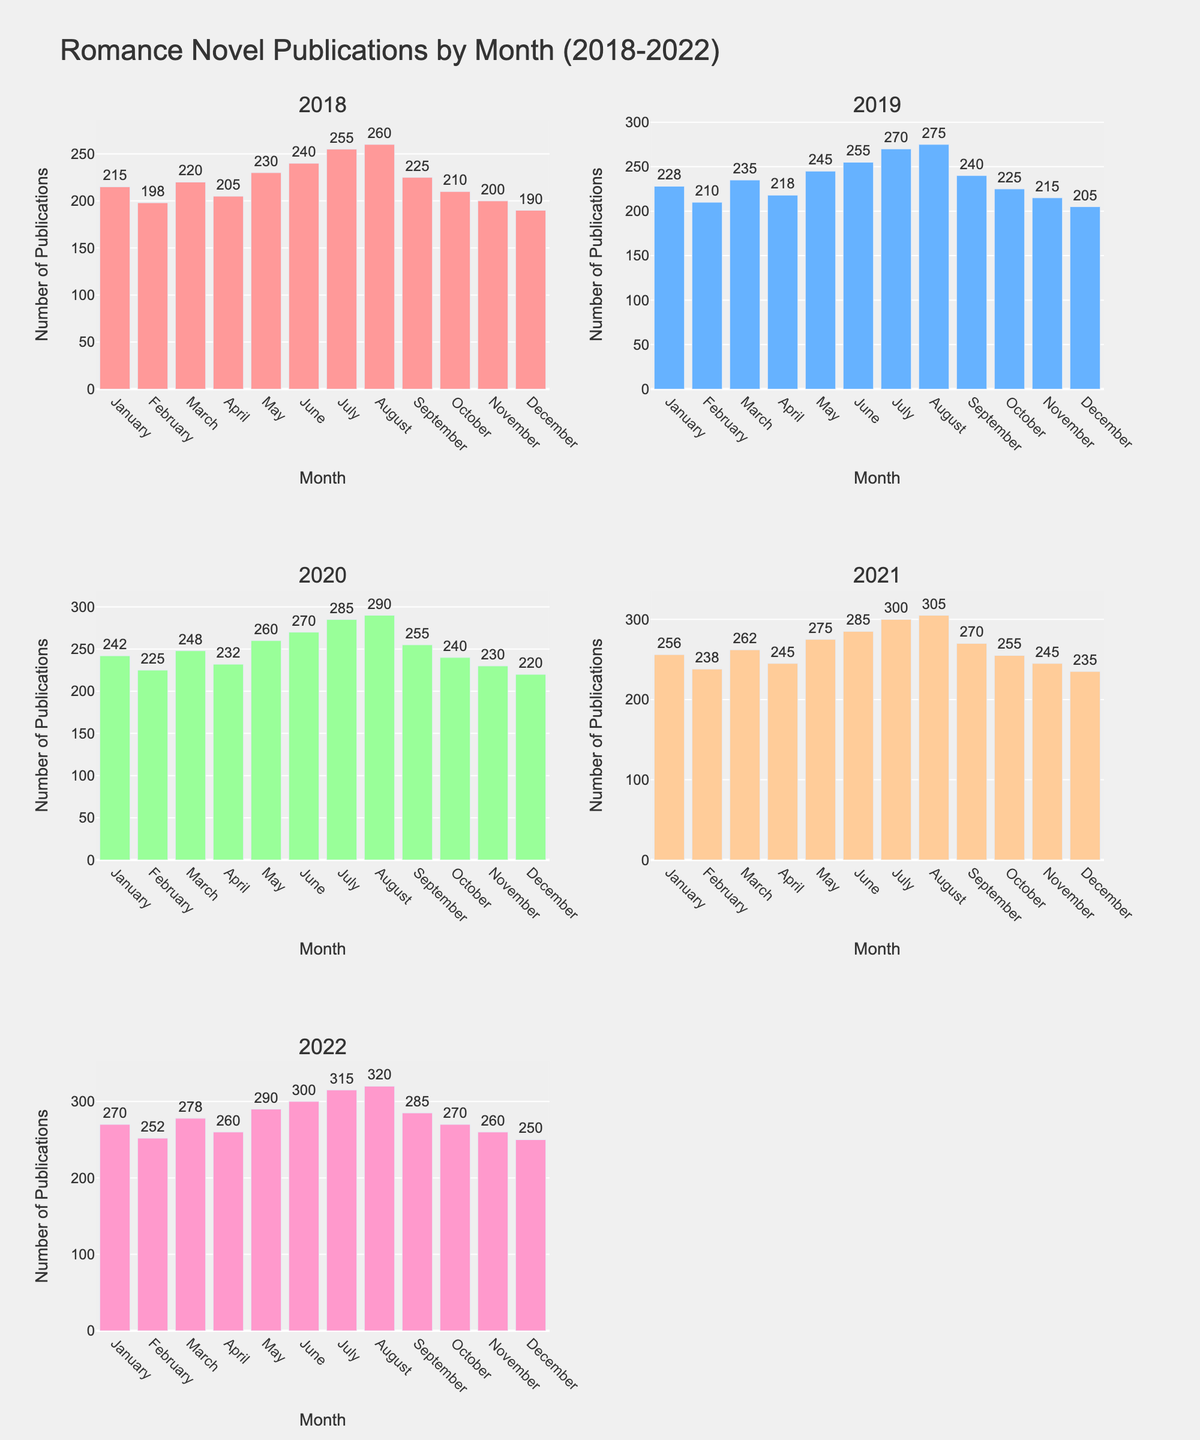What is the title of the figure? The title is located at the top of the figure and clearly states the subject of the visualization.
Answer: "Romance Novel Publications by Month (2018-2022)" What is the highest number of publications in any single month between 2018 and 2022? By looking at the bars across all subplots, the highest bar is for August 2022, which reaches 320 publications.
Answer: 320 Which month consistently shows an increase in publications every year from 2018 to 2022? By examining the bars for each month across the years, August shows a consistent increase in publications from 260 in 2018 to 320 in 2022.
Answer: August What is the total number of publications in May for the year 2020 and 2021 combined? From the subplots for 2020 and 2021, the number of publications in May is 260 and 275 respectively. Adding these together gives 260 + 275 = 535.
Answer: 535 Which month had the smallest number of publications in 2019 and what was the number? By looking at the bars in the 2019 subplot, December had the smallest number of publications, which is 205.
Answer: December, 205 In which year did September have the same number of publications as January of that same year? In 2019, both September and January have the same number of publications, which is 228.
Answer: 2019 How does the number of publications in June 2020 compare to June 2018? The number of publications in June 2020 is 270, and in June 2018 it is 240. The difference is 270 - 240 = 30.
Answer: 30 more in 2020 Which year showed the most growth in the number of publications from February to March? The subplots show the differences between February and March for each year. The largest increase is from February (238) to March (262) in 2021, which is 24 publications.
Answer: 2021 What’s the average number of publications in July across the 5 years? The numbers for July are 255, 270, 285, 300, and 315. Summing these gives 255 + 270 + 285 + 300 + 315 = 1425, and dividing by 5 gives 1425/5 = 285.
Answer: 285 Which year had the smallest increase in the number of publications from one month to the next? By observing the increments in each subplot, in 2019 the increase from January (228) to February (210) shows a decrease rather than an increase, the smallest change which is a drop of 18 publications.
Answer: 2019 